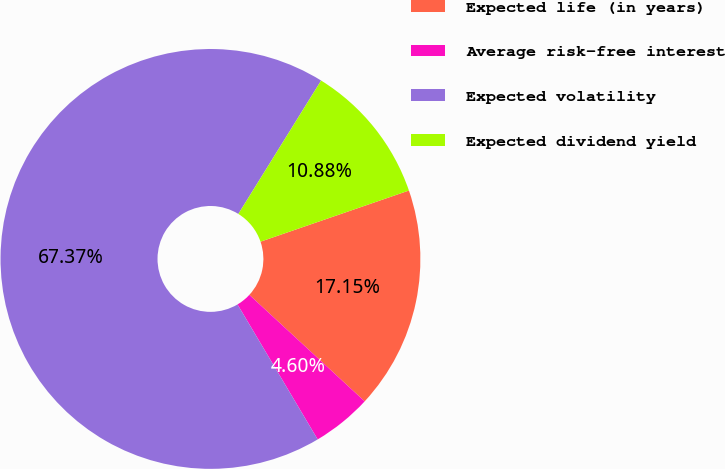<chart> <loc_0><loc_0><loc_500><loc_500><pie_chart><fcel>Expected life (in years)<fcel>Average risk-free interest<fcel>Expected volatility<fcel>Expected dividend yield<nl><fcel>17.15%<fcel>4.6%<fcel>67.37%<fcel>10.88%<nl></chart> 